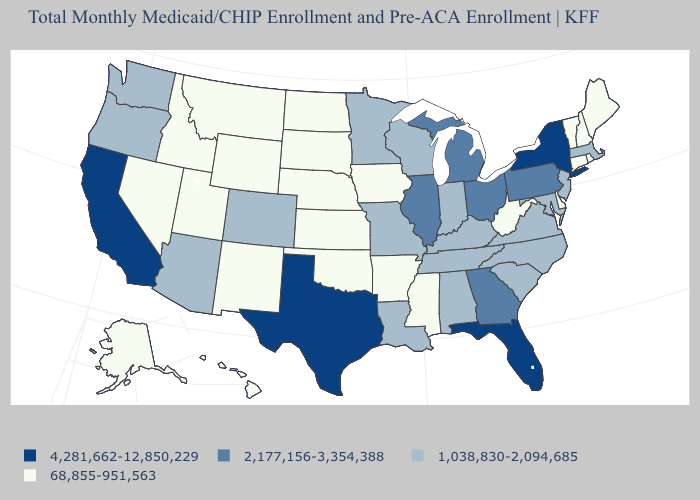What is the highest value in the USA?
Be succinct. 4,281,662-12,850,229. Name the states that have a value in the range 68,855-951,563?
Be succinct. Alaska, Arkansas, Connecticut, Delaware, Hawaii, Idaho, Iowa, Kansas, Maine, Mississippi, Montana, Nebraska, Nevada, New Hampshire, New Mexico, North Dakota, Oklahoma, Rhode Island, South Dakota, Utah, Vermont, West Virginia, Wyoming. Which states have the lowest value in the MidWest?
Give a very brief answer. Iowa, Kansas, Nebraska, North Dakota, South Dakota. What is the value of Florida?
Be succinct. 4,281,662-12,850,229. Does the first symbol in the legend represent the smallest category?
Quick response, please. No. Does Oregon have a higher value than Washington?
Give a very brief answer. No. What is the value of Florida?
Quick response, please. 4,281,662-12,850,229. What is the lowest value in the Northeast?
Answer briefly. 68,855-951,563. Among the states that border New Hampshire , does Massachusetts have the highest value?
Quick response, please. Yes. Which states hav the highest value in the South?
Quick response, please. Florida, Texas. What is the value of Montana?
Concise answer only. 68,855-951,563. What is the value of Wyoming?
Write a very short answer. 68,855-951,563. Which states have the highest value in the USA?
Write a very short answer. California, Florida, New York, Texas. Does Hawaii have the highest value in the West?
Concise answer only. No. Does New Jersey have the same value as Nebraska?
Give a very brief answer. No. 